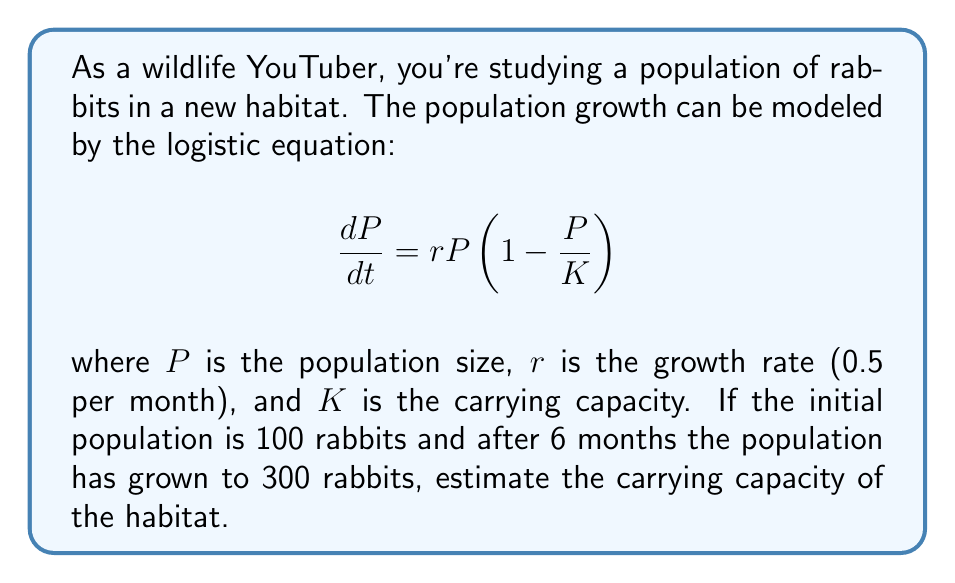Solve this math problem. To solve this problem, we'll use the solution to the logistic equation:

$$P(t) = \frac{K}{1 + \left(\frac{K}{P_0} - 1\right)e^{-rt}}$$

Where $P_0$ is the initial population.

Step 1: Substitute the known values into the equation:
- $P_0 = 100$ (initial population)
- $P(6) = 300$ (population after 6 months)
- $r = 0.5$ (growth rate per month)
- $t = 6$ (time in months)

$$300 = \frac{K}{1 + \left(\frac{K}{100} - 1\right)e^{-0.5 \cdot 6}}$$

Step 2: Simplify the exponential term:
$$300 = \frac{K}{1 + \left(\frac{K}{100} - 1\right)e^{-3}}$$

Step 3: Multiply both sides by the denominator:
$$300 + 300\left(\frac{K}{100} - 1\right)e^{-3} = K$$

Step 4: Expand the brackets:
$$300 + 3Ke^{-3} - 300e^{-3} = K$$

Step 5: Rearrange the equation:
$$K - 3Ke^{-3} = 300 - 300e^{-3}$$

Step 6: Factor out K:
$$K(1 - 3e^{-3}) = 300(1 - e^{-3})$$

Step 7: Solve for K:
$$K = \frac{300(1 - e^{-3})}{1 - 3e^{-3}}$$

Step 8: Calculate the value (rounded to the nearest whole number):
$$K \approx 450$$
Answer: 450 rabbits 